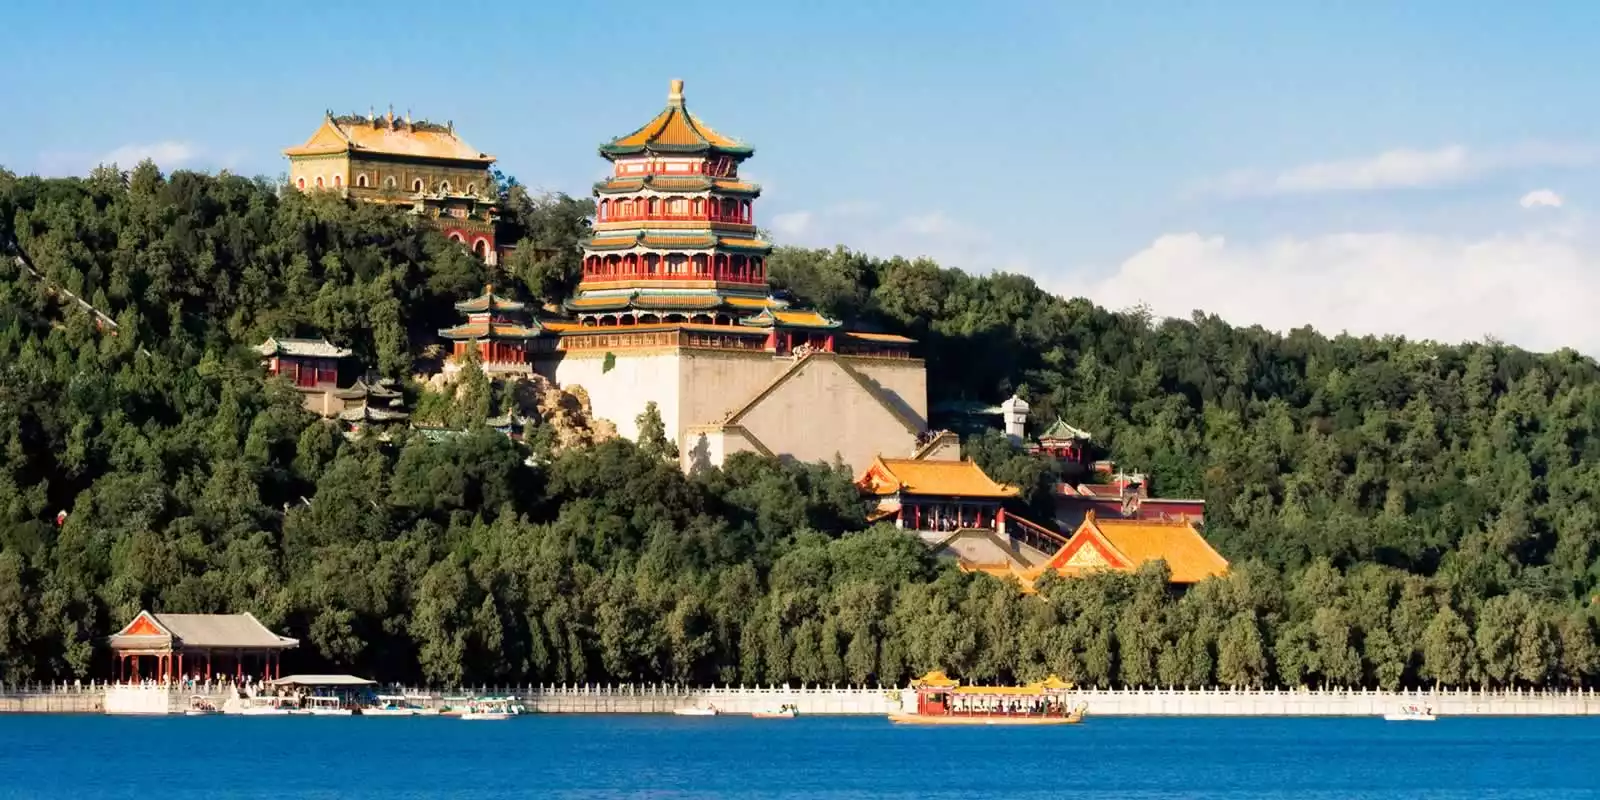How does the presence of the lake enhance the beauty and significance of the Summer Palace? The presence of Kunming Lake not only enhances the aesthetic appeal of the Summer Palace but also plays a significant role in its historical and cultural importance. The tranquil waters of the lake provide a mirror-like surface that beautifully reflects the ornate architecture of the palace, creating a breathtakingly symmetrical vista. This interplay between land and water amplifies the grandeur and serenity of the scene. Historically, the lake was used for naval exercises and leisure boating by the imperial family, adding a dimension of practical use to its beauty. The expanse of water also introduces a cooling effect, offering relief during the hot summer months, making the palace a true oasis. Furthermore, the lake represents the Chinese ideal of harmony between nature and human construction, embodying the philosophical principles of Feng Shui, which advocate for balanced and auspicious living environments. In sum, the lake is a centerpiece that enriches the visual, practical, and philosophical aspects of the Summer Palace, making it a masterpiece of landscape and architectural design. 